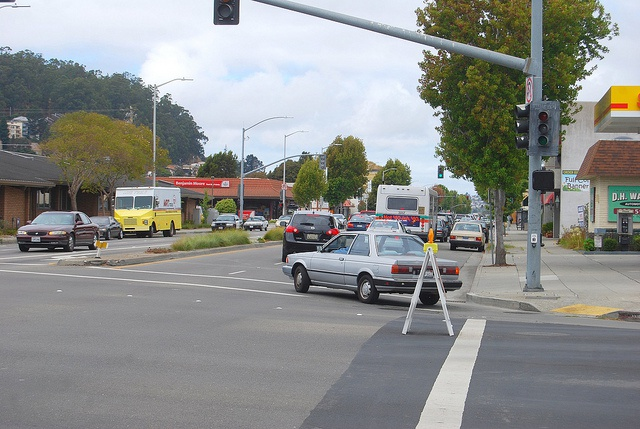Describe the objects in this image and their specific colors. I can see car in darkblue, darkgray, black, gray, and lightgray tones, truck in darkblue, gray, lightgray, khaki, and darkgray tones, car in darkblue, black, darkgray, and gray tones, truck in darkblue, lightgray, gray, and darkgray tones, and bus in darkblue, lightgray, gray, and darkgray tones in this image. 